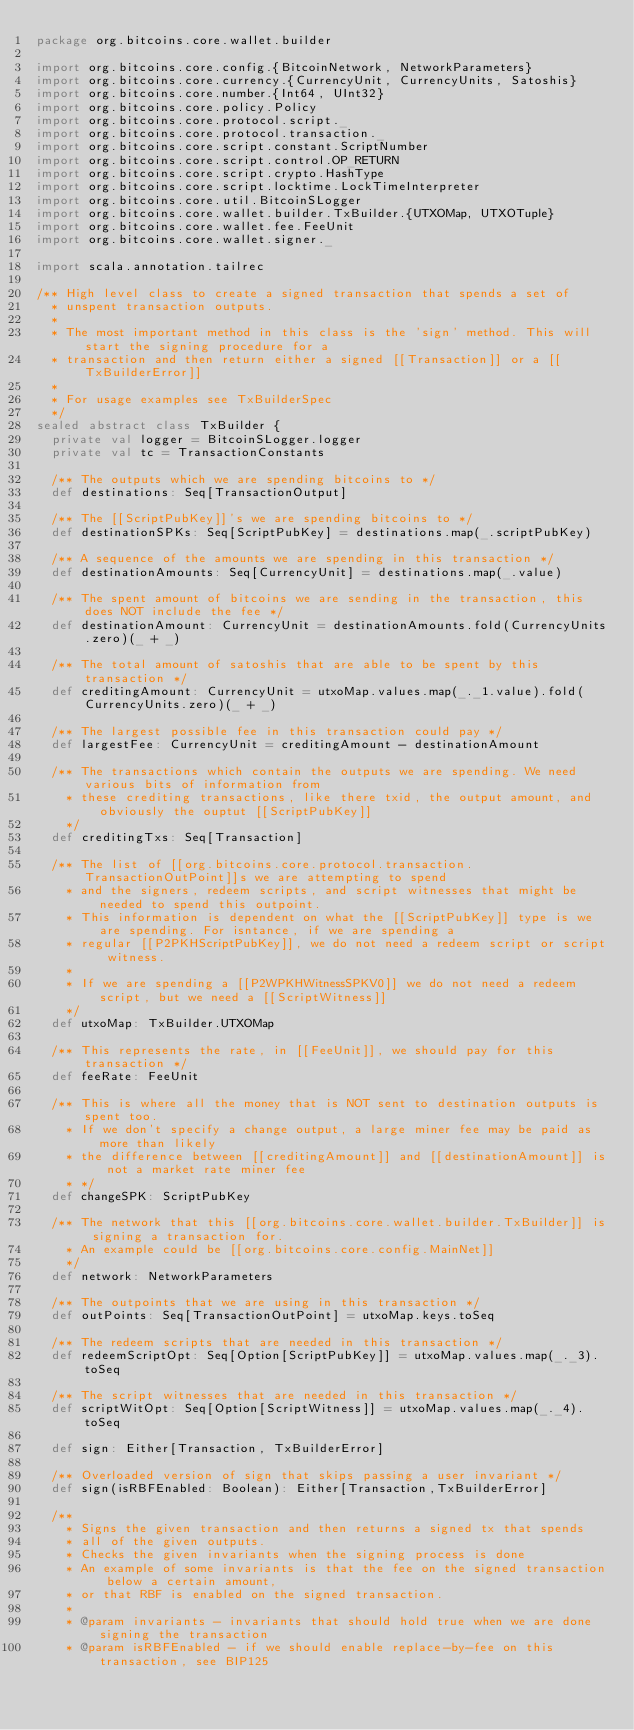Convert code to text. <code><loc_0><loc_0><loc_500><loc_500><_Scala_>package org.bitcoins.core.wallet.builder

import org.bitcoins.core.config.{BitcoinNetwork, NetworkParameters}
import org.bitcoins.core.currency.{CurrencyUnit, CurrencyUnits, Satoshis}
import org.bitcoins.core.number.{Int64, UInt32}
import org.bitcoins.core.policy.Policy
import org.bitcoins.core.protocol.script._
import org.bitcoins.core.protocol.transaction._
import org.bitcoins.core.script.constant.ScriptNumber
import org.bitcoins.core.script.control.OP_RETURN
import org.bitcoins.core.script.crypto.HashType
import org.bitcoins.core.script.locktime.LockTimeInterpreter
import org.bitcoins.core.util.BitcoinSLogger
import org.bitcoins.core.wallet.builder.TxBuilder.{UTXOMap, UTXOTuple}
import org.bitcoins.core.wallet.fee.FeeUnit
import org.bitcoins.core.wallet.signer._

import scala.annotation.tailrec

/** High level class to create a signed transaction that spends a set of
  * unspent transaction outputs.
  *
  * The most important method in this class is the 'sign' method. This will start the signing procedure for a
  * transaction and then return either a signed [[Transaction]] or a [[TxBuilderError]]
  *
  * For usage examples see TxBuilderSpec
  */
sealed abstract class TxBuilder {
  private val logger = BitcoinSLogger.logger
  private val tc = TransactionConstants

  /** The outputs which we are spending bitcoins to */
  def destinations: Seq[TransactionOutput]

  /** The [[ScriptPubKey]]'s we are spending bitcoins to */
  def destinationSPKs: Seq[ScriptPubKey] = destinations.map(_.scriptPubKey)

  /** A sequence of the amounts we are spending in this transaction */
  def destinationAmounts: Seq[CurrencyUnit] = destinations.map(_.value)

  /** The spent amount of bitcoins we are sending in the transaction, this does NOT include the fee */
  def destinationAmount: CurrencyUnit = destinationAmounts.fold(CurrencyUnits.zero)(_ + _)

  /** The total amount of satoshis that are able to be spent by this transaction */
  def creditingAmount: CurrencyUnit = utxoMap.values.map(_._1.value).fold(CurrencyUnits.zero)(_ + _)

  /** The largest possible fee in this transaction could pay */
  def largestFee: CurrencyUnit = creditingAmount - destinationAmount

  /** The transactions which contain the outputs we are spending. We need various bits of information from
    * these crediting transactions, like there txid, the output amount, and obviously the ouptut [[ScriptPubKey]]
    */
  def creditingTxs: Seq[Transaction]

  /** The list of [[org.bitcoins.core.protocol.transaction.TransactionOutPoint]]s we are attempting to spend
    * and the signers, redeem scripts, and script witnesses that might be needed to spend this outpoint.
    * This information is dependent on what the [[ScriptPubKey]] type is we are spending. For isntance, if we are spending a
    * regular [[P2PKHScriptPubKey]], we do not need a redeem script or script witness.
    *
    * If we are spending a [[P2WPKHWitnessSPKV0]] we do not need a redeem script, but we need a [[ScriptWitness]]
    */
  def utxoMap: TxBuilder.UTXOMap

  /** This represents the rate, in [[FeeUnit]], we should pay for this transaction */
  def feeRate: FeeUnit

  /** This is where all the money that is NOT sent to destination outputs is spent too.
    * If we don't specify a change output, a large miner fee may be paid as more than likely
    * the difference between [[creditingAmount]] and [[destinationAmount]] is not a market rate miner fee
    * */
  def changeSPK: ScriptPubKey

  /** The network that this [[org.bitcoins.core.wallet.builder.TxBuilder]] is signing a transaction for.
    * An example could be [[org.bitcoins.core.config.MainNet]]
    */
  def network: NetworkParameters

  /** The outpoints that we are using in this transaction */
  def outPoints: Seq[TransactionOutPoint] = utxoMap.keys.toSeq

  /** The redeem scripts that are needed in this transaction */
  def redeemScriptOpt: Seq[Option[ScriptPubKey]] = utxoMap.values.map(_._3).toSeq

  /** The script witnesses that are needed in this transaction */
  def scriptWitOpt: Seq[Option[ScriptWitness]] = utxoMap.values.map(_._4).toSeq

  def sign: Either[Transaction, TxBuilderError]

  /** Overloaded version of sign that skips passing a user invariant */
  def sign(isRBFEnabled: Boolean): Either[Transaction,TxBuilderError]

  /**
    * Signs the given transaction and then returns a signed tx that spends
    * all of the given outputs.
    * Checks the given invariants when the signing process is done
    * An example of some invariants is that the fee on the signed transaction below a certain amount,
    * or that RBF is enabled on the signed transaction.
    *
    * @param invariants - invariants that should hold true when we are done signing the transaction
    * @param isRBFEnabled - if we should enable replace-by-fee on this transaction, see BIP125</code> 